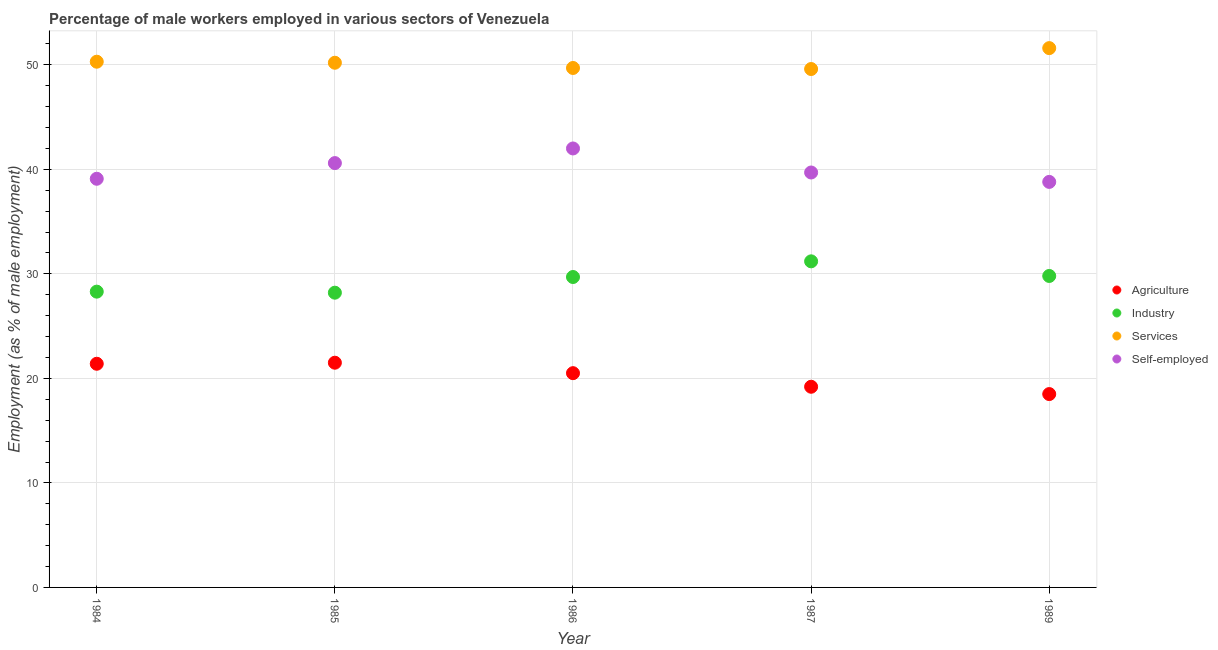Is the number of dotlines equal to the number of legend labels?
Your answer should be compact. Yes. What is the percentage of male workers in industry in 1986?
Offer a very short reply. 29.7. In which year was the percentage of male workers in industry minimum?
Make the answer very short. 1985. What is the total percentage of male workers in industry in the graph?
Provide a succinct answer. 147.2. What is the difference between the percentage of self employed male workers in 1984 and that in 1987?
Ensure brevity in your answer.  -0.6. What is the average percentage of male workers in industry per year?
Ensure brevity in your answer.  29.44. In the year 1989, what is the difference between the percentage of male workers in services and percentage of self employed male workers?
Your answer should be compact. 12.8. What is the ratio of the percentage of self employed male workers in 1984 to that in 1986?
Your answer should be compact. 0.93. What is the difference between the highest and the second highest percentage of self employed male workers?
Make the answer very short. 1.4. What is the difference between the highest and the lowest percentage of male workers in agriculture?
Your response must be concise. 3. In how many years, is the percentage of male workers in agriculture greater than the average percentage of male workers in agriculture taken over all years?
Offer a terse response. 3. Is it the case that in every year, the sum of the percentage of male workers in agriculture and percentage of male workers in industry is greater than the percentage of male workers in services?
Offer a very short reply. No. Is the percentage of male workers in services strictly greater than the percentage of male workers in agriculture over the years?
Your answer should be compact. Yes. Is the percentage of male workers in agriculture strictly less than the percentage of male workers in industry over the years?
Your response must be concise. Yes. What is the difference between two consecutive major ticks on the Y-axis?
Offer a very short reply. 10. Does the graph contain any zero values?
Offer a very short reply. No. What is the title of the graph?
Your response must be concise. Percentage of male workers employed in various sectors of Venezuela. What is the label or title of the X-axis?
Ensure brevity in your answer.  Year. What is the label or title of the Y-axis?
Make the answer very short. Employment (as % of male employment). What is the Employment (as % of male employment) of Agriculture in 1984?
Your response must be concise. 21.4. What is the Employment (as % of male employment) in Industry in 1984?
Make the answer very short. 28.3. What is the Employment (as % of male employment) in Services in 1984?
Offer a very short reply. 50.3. What is the Employment (as % of male employment) of Self-employed in 1984?
Make the answer very short. 39.1. What is the Employment (as % of male employment) in Industry in 1985?
Keep it short and to the point. 28.2. What is the Employment (as % of male employment) in Services in 1985?
Make the answer very short. 50.2. What is the Employment (as % of male employment) of Self-employed in 1985?
Offer a terse response. 40.6. What is the Employment (as % of male employment) of Agriculture in 1986?
Provide a succinct answer. 20.5. What is the Employment (as % of male employment) of Industry in 1986?
Give a very brief answer. 29.7. What is the Employment (as % of male employment) of Services in 1986?
Give a very brief answer. 49.7. What is the Employment (as % of male employment) in Agriculture in 1987?
Provide a short and direct response. 19.2. What is the Employment (as % of male employment) in Industry in 1987?
Provide a short and direct response. 31.2. What is the Employment (as % of male employment) in Services in 1987?
Your answer should be compact. 49.6. What is the Employment (as % of male employment) in Self-employed in 1987?
Ensure brevity in your answer.  39.7. What is the Employment (as % of male employment) of Industry in 1989?
Provide a short and direct response. 29.8. What is the Employment (as % of male employment) of Services in 1989?
Keep it short and to the point. 51.6. What is the Employment (as % of male employment) of Self-employed in 1989?
Your answer should be very brief. 38.8. Across all years, what is the maximum Employment (as % of male employment) of Industry?
Offer a terse response. 31.2. Across all years, what is the maximum Employment (as % of male employment) of Services?
Keep it short and to the point. 51.6. Across all years, what is the maximum Employment (as % of male employment) in Self-employed?
Make the answer very short. 42. Across all years, what is the minimum Employment (as % of male employment) in Agriculture?
Your response must be concise. 18.5. Across all years, what is the minimum Employment (as % of male employment) of Industry?
Ensure brevity in your answer.  28.2. Across all years, what is the minimum Employment (as % of male employment) in Services?
Offer a very short reply. 49.6. Across all years, what is the minimum Employment (as % of male employment) in Self-employed?
Make the answer very short. 38.8. What is the total Employment (as % of male employment) of Agriculture in the graph?
Offer a very short reply. 101.1. What is the total Employment (as % of male employment) of Industry in the graph?
Your answer should be very brief. 147.2. What is the total Employment (as % of male employment) in Services in the graph?
Make the answer very short. 251.4. What is the total Employment (as % of male employment) in Self-employed in the graph?
Offer a terse response. 200.2. What is the difference between the Employment (as % of male employment) in Services in 1984 and that in 1985?
Your answer should be compact. 0.1. What is the difference between the Employment (as % of male employment) of Self-employed in 1984 and that in 1985?
Offer a very short reply. -1.5. What is the difference between the Employment (as % of male employment) of Agriculture in 1984 and that in 1986?
Give a very brief answer. 0.9. What is the difference between the Employment (as % of male employment) of Agriculture in 1984 and that in 1987?
Your response must be concise. 2.2. What is the difference between the Employment (as % of male employment) of Industry in 1984 and that in 1987?
Provide a succinct answer. -2.9. What is the difference between the Employment (as % of male employment) of Services in 1984 and that in 1987?
Your response must be concise. 0.7. What is the difference between the Employment (as % of male employment) in Agriculture in 1984 and that in 1989?
Keep it short and to the point. 2.9. What is the difference between the Employment (as % of male employment) of Industry in 1984 and that in 1989?
Make the answer very short. -1.5. What is the difference between the Employment (as % of male employment) of Services in 1984 and that in 1989?
Offer a terse response. -1.3. What is the difference between the Employment (as % of male employment) in Services in 1985 and that in 1986?
Make the answer very short. 0.5. What is the difference between the Employment (as % of male employment) of Agriculture in 1985 and that in 1989?
Your answer should be very brief. 3. What is the difference between the Employment (as % of male employment) of Services in 1985 and that in 1989?
Ensure brevity in your answer.  -1.4. What is the difference between the Employment (as % of male employment) of Self-employed in 1985 and that in 1989?
Keep it short and to the point. 1.8. What is the difference between the Employment (as % of male employment) of Services in 1986 and that in 1987?
Provide a short and direct response. 0.1. What is the difference between the Employment (as % of male employment) in Self-employed in 1986 and that in 1989?
Your response must be concise. 3.2. What is the difference between the Employment (as % of male employment) in Agriculture in 1984 and the Employment (as % of male employment) in Industry in 1985?
Give a very brief answer. -6.8. What is the difference between the Employment (as % of male employment) in Agriculture in 1984 and the Employment (as % of male employment) in Services in 1985?
Your answer should be compact. -28.8. What is the difference between the Employment (as % of male employment) in Agriculture in 1984 and the Employment (as % of male employment) in Self-employed in 1985?
Offer a terse response. -19.2. What is the difference between the Employment (as % of male employment) of Industry in 1984 and the Employment (as % of male employment) of Services in 1985?
Keep it short and to the point. -21.9. What is the difference between the Employment (as % of male employment) in Industry in 1984 and the Employment (as % of male employment) in Self-employed in 1985?
Your answer should be very brief. -12.3. What is the difference between the Employment (as % of male employment) of Agriculture in 1984 and the Employment (as % of male employment) of Industry in 1986?
Offer a terse response. -8.3. What is the difference between the Employment (as % of male employment) in Agriculture in 1984 and the Employment (as % of male employment) in Services in 1986?
Your answer should be very brief. -28.3. What is the difference between the Employment (as % of male employment) in Agriculture in 1984 and the Employment (as % of male employment) in Self-employed in 1986?
Keep it short and to the point. -20.6. What is the difference between the Employment (as % of male employment) in Industry in 1984 and the Employment (as % of male employment) in Services in 1986?
Provide a succinct answer. -21.4. What is the difference between the Employment (as % of male employment) in Industry in 1984 and the Employment (as % of male employment) in Self-employed in 1986?
Ensure brevity in your answer.  -13.7. What is the difference between the Employment (as % of male employment) in Services in 1984 and the Employment (as % of male employment) in Self-employed in 1986?
Provide a succinct answer. 8.3. What is the difference between the Employment (as % of male employment) of Agriculture in 1984 and the Employment (as % of male employment) of Industry in 1987?
Make the answer very short. -9.8. What is the difference between the Employment (as % of male employment) of Agriculture in 1984 and the Employment (as % of male employment) of Services in 1987?
Offer a very short reply. -28.2. What is the difference between the Employment (as % of male employment) of Agriculture in 1984 and the Employment (as % of male employment) of Self-employed in 1987?
Offer a very short reply. -18.3. What is the difference between the Employment (as % of male employment) in Industry in 1984 and the Employment (as % of male employment) in Services in 1987?
Your answer should be very brief. -21.3. What is the difference between the Employment (as % of male employment) of Services in 1984 and the Employment (as % of male employment) of Self-employed in 1987?
Ensure brevity in your answer.  10.6. What is the difference between the Employment (as % of male employment) in Agriculture in 1984 and the Employment (as % of male employment) in Industry in 1989?
Offer a terse response. -8.4. What is the difference between the Employment (as % of male employment) in Agriculture in 1984 and the Employment (as % of male employment) in Services in 1989?
Keep it short and to the point. -30.2. What is the difference between the Employment (as % of male employment) in Agriculture in 1984 and the Employment (as % of male employment) in Self-employed in 1989?
Give a very brief answer. -17.4. What is the difference between the Employment (as % of male employment) of Industry in 1984 and the Employment (as % of male employment) of Services in 1989?
Make the answer very short. -23.3. What is the difference between the Employment (as % of male employment) in Services in 1984 and the Employment (as % of male employment) in Self-employed in 1989?
Give a very brief answer. 11.5. What is the difference between the Employment (as % of male employment) in Agriculture in 1985 and the Employment (as % of male employment) in Services in 1986?
Ensure brevity in your answer.  -28.2. What is the difference between the Employment (as % of male employment) of Agriculture in 1985 and the Employment (as % of male employment) of Self-employed in 1986?
Keep it short and to the point. -20.5. What is the difference between the Employment (as % of male employment) in Industry in 1985 and the Employment (as % of male employment) in Services in 1986?
Provide a succinct answer. -21.5. What is the difference between the Employment (as % of male employment) in Services in 1985 and the Employment (as % of male employment) in Self-employed in 1986?
Give a very brief answer. 8.2. What is the difference between the Employment (as % of male employment) of Agriculture in 1985 and the Employment (as % of male employment) of Services in 1987?
Your answer should be very brief. -28.1. What is the difference between the Employment (as % of male employment) in Agriculture in 1985 and the Employment (as % of male employment) in Self-employed in 1987?
Your answer should be compact. -18.2. What is the difference between the Employment (as % of male employment) of Industry in 1985 and the Employment (as % of male employment) of Services in 1987?
Make the answer very short. -21.4. What is the difference between the Employment (as % of male employment) in Services in 1985 and the Employment (as % of male employment) in Self-employed in 1987?
Your response must be concise. 10.5. What is the difference between the Employment (as % of male employment) in Agriculture in 1985 and the Employment (as % of male employment) in Industry in 1989?
Your answer should be compact. -8.3. What is the difference between the Employment (as % of male employment) of Agriculture in 1985 and the Employment (as % of male employment) of Services in 1989?
Your response must be concise. -30.1. What is the difference between the Employment (as % of male employment) of Agriculture in 1985 and the Employment (as % of male employment) of Self-employed in 1989?
Your answer should be very brief. -17.3. What is the difference between the Employment (as % of male employment) in Industry in 1985 and the Employment (as % of male employment) in Services in 1989?
Provide a succinct answer. -23.4. What is the difference between the Employment (as % of male employment) of Industry in 1985 and the Employment (as % of male employment) of Self-employed in 1989?
Offer a very short reply. -10.6. What is the difference between the Employment (as % of male employment) in Services in 1985 and the Employment (as % of male employment) in Self-employed in 1989?
Your answer should be compact. 11.4. What is the difference between the Employment (as % of male employment) in Agriculture in 1986 and the Employment (as % of male employment) in Services in 1987?
Give a very brief answer. -29.1. What is the difference between the Employment (as % of male employment) in Agriculture in 1986 and the Employment (as % of male employment) in Self-employed in 1987?
Provide a short and direct response. -19.2. What is the difference between the Employment (as % of male employment) in Industry in 1986 and the Employment (as % of male employment) in Services in 1987?
Provide a succinct answer. -19.9. What is the difference between the Employment (as % of male employment) of Industry in 1986 and the Employment (as % of male employment) of Self-employed in 1987?
Provide a short and direct response. -10. What is the difference between the Employment (as % of male employment) of Agriculture in 1986 and the Employment (as % of male employment) of Industry in 1989?
Your response must be concise. -9.3. What is the difference between the Employment (as % of male employment) of Agriculture in 1986 and the Employment (as % of male employment) of Services in 1989?
Your answer should be compact. -31.1. What is the difference between the Employment (as % of male employment) in Agriculture in 1986 and the Employment (as % of male employment) in Self-employed in 1989?
Your response must be concise. -18.3. What is the difference between the Employment (as % of male employment) in Industry in 1986 and the Employment (as % of male employment) in Services in 1989?
Make the answer very short. -21.9. What is the difference between the Employment (as % of male employment) in Agriculture in 1987 and the Employment (as % of male employment) in Industry in 1989?
Your answer should be compact. -10.6. What is the difference between the Employment (as % of male employment) of Agriculture in 1987 and the Employment (as % of male employment) of Services in 1989?
Make the answer very short. -32.4. What is the difference between the Employment (as % of male employment) of Agriculture in 1987 and the Employment (as % of male employment) of Self-employed in 1989?
Give a very brief answer. -19.6. What is the difference between the Employment (as % of male employment) of Industry in 1987 and the Employment (as % of male employment) of Services in 1989?
Ensure brevity in your answer.  -20.4. What is the difference between the Employment (as % of male employment) of Industry in 1987 and the Employment (as % of male employment) of Self-employed in 1989?
Offer a terse response. -7.6. What is the difference between the Employment (as % of male employment) in Services in 1987 and the Employment (as % of male employment) in Self-employed in 1989?
Your answer should be compact. 10.8. What is the average Employment (as % of male employment) in Agriculture per year?
Make the answer very short. 20.22. What is the average Employment (as % of male employment) of Industry per year?
Offer a terse response. 29.44. What is the average Employment (as % of male employment) of Services per year?
Your answer should be compact. 50.28. What is the average Employment (as % of male employment) in Self-employed per year?
Ensure brevity in your answer.  40.04. In the year 1984, what is the difference between the Employment (as % of male employment) in Agriculture and Employment (as % of male employment) in Services?
Ensure brevity in your answer.  -28.9. In the year 1984, what is the difference between the Employment (as % of male employment) in Agriculture and Employment (as % of male employment) in Self-employed?
Your response must be concise. -17.7. In the year 1985, what is the difference between the Employment (as % of male employment) of Agriculture and Employment (as % of male employment) of Industry?
Provide a short and direct response. -6.7. In the year 1985, what is the difference between the Employment (as % of male employment) in Agriculture and Employment (as % of male employment) in Services?
Your response must be concise. -28.7. In the year 1985, what is the difference between the Employment (as % of male employment) of Agriculture and Employment (as % of male employment) of Self-employed?
Your response must be concise. -19.1. In the year 1985, what is the difference between the Employment (as % of male employment) in Industry and Employment (as % of male employment) in Services?
Provide a succinct answer. -22. In the year 1986, what is the difference between the Employment (as % of male employment) of Agriculture and Employment (as % of male employment) of Services?
Provide a succinct answer. -29.2. In the year 1986, what is the difference between the Employment (as % of male employment) in Agriculture and Employment (as % of male employment) in Self-employed?
Provide a short and direct response. -21.5. In the year 1986, what is the difference between the Employment (as % of male employment) in Industry and Employment (as % of male employment) in Services?
Make the answer very short. -20. In the year 1987, what is the difference between the Employment (as % of male employment) in Agriculture and Employment (as % of male employment) in Services?
Ensure brevity in your answer.  -30.4. In the year 1987, what is the difference between the Employment (as % of male employment) in Agriculture and Employment (as % of male employment) in Self-employed?
Make the answer very short. -20.5. In the year 1987, what is the difference between the Employment (as % of male employment) in Industry and Employment (as % of male employment) in Services?
Ensure brevity in your answer.  -18.4. In the year 1987, what is the difference between the Employment (as % of male employment) of Industry and Employment (as % of male employment) of Self-employed?
Keep it short and to the point. -8.5. In the year 1989, what is the difference between the Employment (as % of male employment) of Agriculture and Employment (as % of male employment) of Industry?
Provide a short and direct response. -11.3. In the year 1989, what is the difference between the Employment (as % of male employment) of Agriculture and Employment (as % of male employment) of Services?
Your response must be concise. -33.1. In the year 1989, what is the difference between the Employment (as % of male employment) in Agriculture and Employment (as % of male employment) in Self-employed?
Keep it short and to the point. -20.3. In the year 1989, what is the difference between the Employment (as % of male employment) in Industry and Employment (as % of male employment) in Services?
Your response must be concise. -21.8. In the year 1989, what is the difference between the Employment (as % of male employment) in Industry and Employment (as % of male employment) in Self-employed?
Your answer should be very brief. -9. In the year 1989, what is the difference between the Employment (as % of male employment) in Services and Employment (as % of male employment) in Self-employed?
Give a very brief answer. 12.8. What is the ratio of the Employment (as % of male employment) in Industry in 1984 to that in 1985?
Make the answer very short. 1. What is the ratio of the Employment (as % of male employment) in Self-employed in 1984 to that in 1985?
Provide a succinct answer. 0.96. What is the ratio of the Employment (as % of male employment) of Agriculture in 1984 to that in 1986?
Your answer should be compact. 1.04. What is the ratio of the Employment (as % of male employment) in Industry in 1984 to that in 1986?
Keep it short and to the point. 0.95. What is the ratio of the Employment (as % of male employment) of Services in 1984 to that in 1986?
Make the answer very short. 1.01. What is the ratio of the Employment (as % of male employment) of Agriculture in 1984 to that in 1987?
Offer a terse response. 1.11. What is the ratio of the Employment (as % of male employment) of Industry in 1984 to that in 1987?
Your answer should be compact. 0.91. What is the ratio of the Employment (as % of male employment) of Services in 1984 to that in 1987?
Keep it short and to the point. 1.01. What is the ratio of the Employment (as % of male employment) of Self-employed in 1984 to that in 1987?
Your response must be concise. 0.98. What is the ratio of the Employment (as % of male employment) of Agriculture in 1984 to that in 1989?
Provide a succinct answer. 1.16. What is the ratio of the Employment (as % of male employment) of Industry in 1984 to that in 1989?
Your answer should be compact. 0.95. What is the ratio of the Employment (as % of male employment) of Services in 1984 to that in 1989?
Provide a short and direct response. 0.97. What is the ratio of the Employment (as % of male employment) of Self-employed in 1984 to that in 1989?
Provide a short and direct response. 1.01. What is the ratio of the Employment (as % of male employment) in Agriculture in 1985 to that in 1986?
Make the answer very short. 1.05. What is the ratio of the Employment (as % of male employment) of Industry in 1985 to that in 1986?
Provide a succinct answer. 0.95. What is the ratio of the Employment (as % of male employment) in Services in 1985 to that in 1986?
Your answer should be very brief. 1.01. What is the ratio of the Employment (as % of male employment) of Self-employed in 1985 to that in 1986?
Offer a terse response. 0.97. What is the ratio of the Employment (as % of male employment) in Agriculture in 1985 to that in 1987?
Keep it short and to the point. 1.12. What is the ratio of the Employment (as % of male employment) in Industry in 1985 to that in 1987?
Your response must be concise. 0.9. What is the ratio of the Employment (as % of male employment) of Services in 1985 to that in 1987?
Provide a succinct answer. 1.01. What is the ratio of the Employment (as % of male employment) in Self-employed in 1985 to that in 1987?
Your answer should be very brief. 1.02. What is the ratio of the Employment (as % of male employment) of Agriculture in 1985 to that in 1989?
Your answer should be very brief. 1.16. What is the ratio of the Employment (as % of male employment) in Industry in 1985 to that in 1989?
Ensure brevity in your answer.  0.95. What is the ratio of the Employment (as % of male employment) of Services in 1985 to that in 1989?
Your answer should be compact. 0.97. What is the ratio of the Employment (as % of male employment) in Self-employed in 1985 to that in 1989?
Make the answer very short. 1.05. What is the ratio of the Employment (as % of male employment) in Agriculture in 1986 to that in 1987?
Give a very brief answer. 1.07. What is the ratio of the Employment (as % of male employment) in Industry in 1986 to that in 1987?
Give a very brief answer. 0.95. What is the ratio of the Employment (as % of male employment) in Self-employed in 1986 to that in 1987?
Your answer should be compact. 1.06. What is the ratio of the Employment (as % of male employment) of Agriculture in 1986 to that in 1989?
Your response must be concise. 1.11. What is the ratio of the Employment (as % of male employment) of Services in 1986 to that in 1989?
Your answer should be very brief. 0.96. What is the ratio of the Employment (as % of male employment) of Self-employed in 1986 to that in 1989?
Keep it short and to the point. 1.08. What is the ratio of the Employment (as % of male employment) of Agriculture in 1987 to that in 1989?
Offer a very short reply. 1.04. What is the ratio of the Employment (as % of male employment) of Industry in 1987 to that in 1989?
Your response must be concise. 1.05. What is the ratio of the Employment (as % of male employment) of Services in 1987 to that in 1989?
Ensure brevity in your answer.  0.96. What is the ratio of the Employment (as % of male employment) of Self-employed in 1987 to that in 1989?
Your answer should be compact. 1.02. What is the difference between the highest and the second highest Employment (as % of male employment) in Agriculture?
Make the answer very short. 0.1. What is the difference between the highest and the second highest Employment (as % of male employment) in Self-employed?
Offer a very short reply. 1.4. What is the difference between the highest and the lowest Employment (as % of male employment) of Agriculture?
Keep it short and to the point. 3. What is the difference between the highest and the lowest Employment (as % of male employment) of Industry?
Your answer should be compact. 3. What is the difference between the highest and the lowest Employment (as % of male employment) of Services?
Offer a very short reply. 2. 